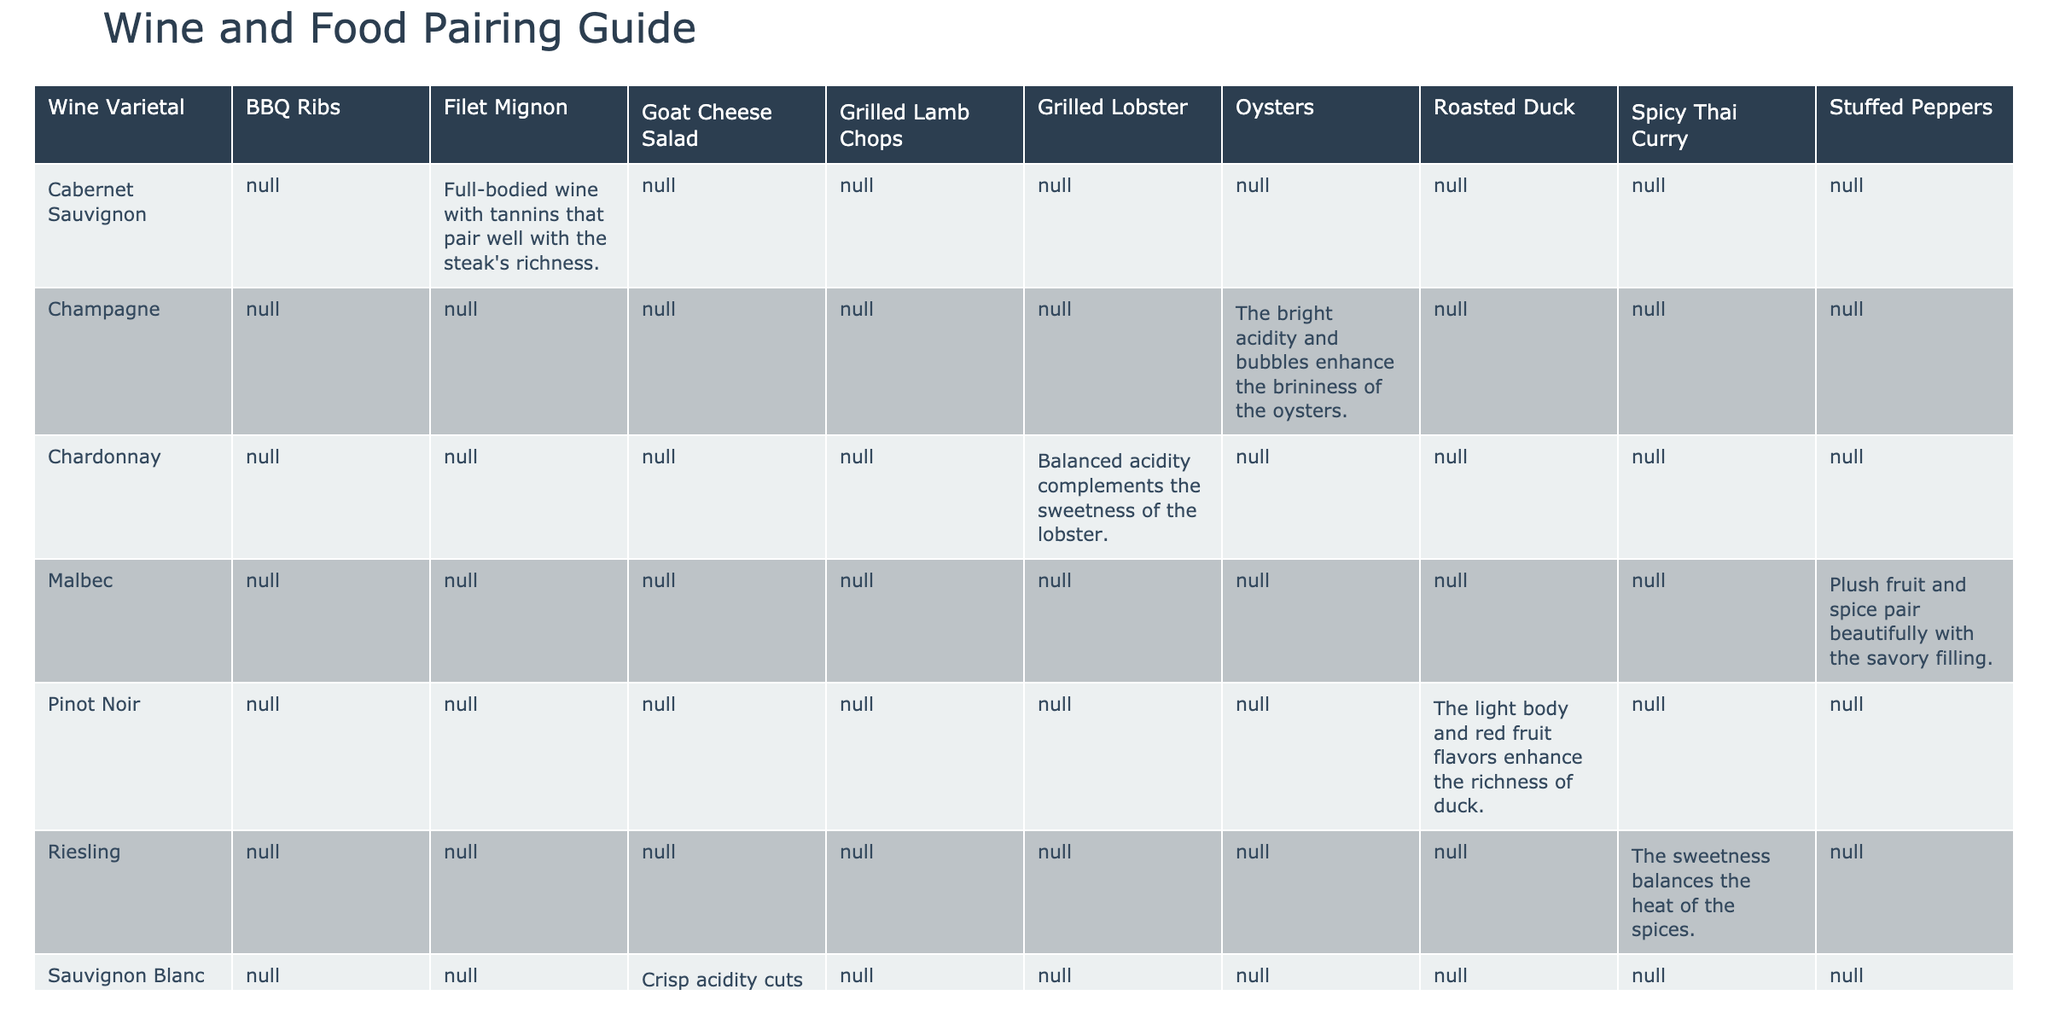What wine varietal pairs with grilled lobster? According to the table, Chardonnay is listed as the wine varietal that pairs with grilled lobster.
Answer: Chardonnay Which menu item pairs with Sauvignon Blanc? The table shows that Sauvignon Blanc pairs well with Goat Cheese Salad.
Answer: Goat Cheese Salad Is Riesling a good pairing for BBQ Ribs? The table does not list Riesling as a pairing for BBQ Ribs; it instead shows that Zinfandel pairs with BBQ Ribs. Therefore, the answer is no.
Answer: No What is the pairing note for Pinot Noir and Roasted Duck? The table indicates that the pairing note for Pinot Noir with Roasted Duck is that the light body and red fruit flavors enhance the richness of the duck.
Answer: The light body and red fruit flavors enhance the richness of duck How many wine varietals are mentioned in the table that pair with salad items? The table lists two salad pairings: Sauvignon Blanc with Goat Cheese Salad, and there are no other salad items mentioned. Hence, there is only one varietal.
Answer: 1 